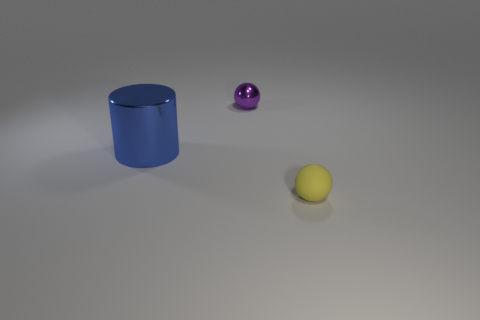Subtract all yellow balls. How many balls are left? 1 Add 1 yellow objects. How many objects exist? 4 Subtract all cylinders. How many objects are left? 2 Subtract 1 cylinders. How many cylinders are left? 0 Add 3 metallic cylinders. How many metallic cylinders are left? 4 Add 3 yellow objects. How many yellow objects exist? 4 Subtract 0 blue balls. How many objects are left? 3 Subtract all cyan spheres. Subtract all yellow cubes. How many spheres are left? 2 Subtract all small gray matte objects. Subtract all purple metallic spheres. How many objects are left? 2 